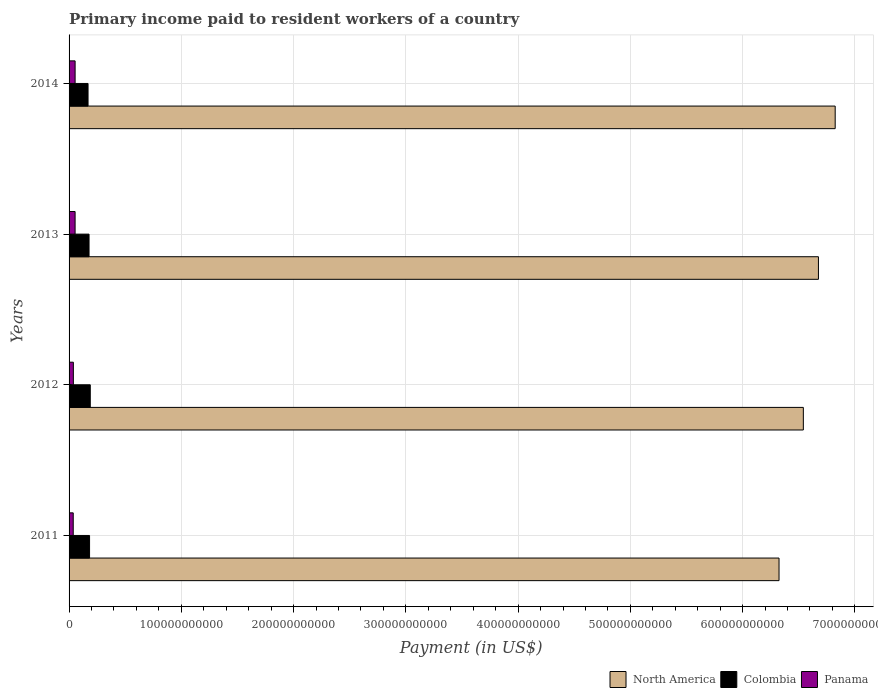Are the number of bars on each tick of the Y-axis equal?
Make the answer very short. Yes. What is the label of the 2nd group of bars from the top?
Provide a short and direct response. 2013. What is the amount paid to workers in North America in 2014?
Provide a short and direct response. 6.82e+11. Across all years, what is the maximum amount paid to workers in Colombia?
Your response must be concise. 1.89e+1. Across all years, what is the minimum amount paid to workers in Colombia?
Keep it short and to the point. 1.69e+1. What is the total amount paid to workers in Colombia in the graph?
Offer a very short reply. 7.18e+1. What is the difference between the amount paid to workers in North America in 2013 and that in 2014?
Give a very brief answer. -1.49e+1. What is the difference between the amount paid to workers in Panama in 2011 and the amount paid to workers in Colombia in 2012?
Your answer should be very brief. -1.52e+1. What is the average amount paid to workers in North America per year?
Provide a short and direct response. 6.59e+11. In the year 2012, what is the difference between the amount paid to workers in Colombia and amount paid to workers in Panama?
Your answer should be very brief. 1.51e+1. What is the ratio of the amount paid to workers in Colombia in 2012 to that in 2013?
Your response must be concise. 1.06. What is the difference between the highest and the second highest amount paid to workers in Panama?
Make the answer very short. 8.10e+06. What is the difference between the highest and the lowest amount paid to workers in North America?
Offer a terse response. 5.00e+1. Is the sum of the amount paid to workers in Colombia in 2011 and 2012 greater than the maximum amount paid to workers in Panama across all years?
Ensure brevity in your answer.  Yes. What does the 1st bar from the top in 2013 represents?
Keep it short and to the point. Panama. What does the 3rd bar from the bottom in 2012 represents?
Your answer should be compact. Panama. Is it the case that in every year, the sum of the amount paid to workers in North America and amount paid to workers in Colombia is greater than the amount paid to workers in Panama?
Your response must be concise. Yes. How many bars are there?
Your answer should be compact. 12. Are all the bars in the graph horizontal?
Ensure brevity in your answer.  Yes. How many years are there in the graph?
Give a very brief answer. 4. What is the difference between two consecutive major ticks on the X-axis?
Your response must be concise. 1.00e+11. Are the values on the major ticks of X-axis written in scientific E-notation?
Provide a succinct answer. No. Does the graph contain grids?
Ensure brevity in your answer.  Yes. How many legend labels are there?
Provide a short and direct response. 3. How are the legend labels stacked?
Make the answer very short. Horizontal. What is the title of the graph?
Give a very brief answer. Primary income paid to resident workers of a country. What is the label or title of the X-axis?
Offer a terse response. Payment (in US$). What is the label or title of the Y-axis?
Give a very brief answer. Years. What is the Payment (in US$) in North America in 2011?
Provide a short and direct response. 6.32e+11. What is the Payment (in US$) in Colombia in 2011?
Provide a succinct answer. 1.83e+1. What is the Payment (in US$) of Panama in 2011?
Keep it short and to the point. 3.71e+09. What is the Payment (in US$) of North America in 2012?
Provide a succinct answer. 6.54e+11. What is the Payment (in US$) in Colombia in 2012?
Your answer should be very brief. 1.89e+1. What is the Payment (in US$) of Panama in 2012?
Your answer should be very brief. 3.83e+09. What is the Payment (in US$) of North America in 2013?
Provide a succinct answer. 6.68e+11. What is the Payment (in US$) of Colombia in 2013?
Offer a very short reply. 1.78e+1. What is the Payment (in US$) of Panama in 2013?
Offer a terse response. 5.37e+09. What is the Payment (in US$) in North America in 2014?
Your response must be concise. 6.82e+11. What is the Payment (in US$) of Colombia in 2014?
Your answer should be very brief. 1.69e+1. What is the Payment (in US$) in Panama in 2014?
Give a very brief answer. 5.37e+09. Across all years, what is the maximum Payment (in US$) in North America?
Your response must be concise. 6.82e+11. Across all years, what is the maximum Payment (in US$) in Colombia?
Make the answer very short. 1.89e+1. Across all years, what is the maximum Payment (in US$) of Panama?
Your response must be concise. 5.37e+09. Across all years, what is the minimum Payment (in US$) in North America?
Make the answer very short. 6.32e+11. Across all years, what is the minimum Payment (in US$) in Colombia?
Give a very brief answer. 1.69e+1. Across all years, what is the minimum Payment (in US$) in Panama?
Provide a succinct answer. 3.71e+09. What is the total Payment (in US$) of North America in the graph?
Your answer should be very brief. 2.64e+12. What is the total Payment (in US$) in Colombia in the graph?
Provide a short and direct response. 7.18e+1. What is the total Payment (in US$) in Panama in the graph?
Your response must be concise. 1.83e+1. What is the difference between the Payment (in US$) in North America in 2011 and that in 2012?
Provide a short and direct response. -2.17e+1. What is the difference between the Payment (in US$) in Colombia in 2011 and that in 2012?
Ensure brevity in your answer.  -6.22e+08. What is the difference between the Payment (in US$) in Panama in 2011 and that in 2012?
Give a very brief answer. -1.19e+08. What is the difference between the Payment (in US$) of North America in 2011 and that in 2013?
Give a very brief answer. -3.51e+1. What is the difference between the Payment (in US$) in Colombia in 2011 and that in 2013?
Provide a succinct answer. 4.71e+08. What is the difference between the Payment (in US$) of Panama in 2011 and that in 2013?
Your answer should be compact. -1.66e+09. What is the difference between the Payment (in US$) in North America in 2011 and that in 2014?
Offer a very short reply. -5.00e+1. What is the difference between the Payment (in US$) in Colombia in 2011 and that in 2014?
Provide a short and direct response. 1.36e+09. What is the difference between the Payment (in US$) in Panama in 2011 and that in 2014?
Your answer should be compact. -1.67e+09. What is the difference between the Payment (in US$) of North America in 2012 and that in 2013?
Keep it short and to the point. -1.34e+1. What is the difference between the Payment (in US$) of Colombia in 2012 and that in 2013?
Your answer should be very brief. 1.09e+09. What is the difference between the Payment (in US$) in Panama in 2012 and that in 2013?
Your answer should be compact. -1.54e+09. What is the difference between the Payment (in US$) in North America in 2012 and that in 2014?
Make the answer very short. -2.84e+1. What is the difference between the Payment (in US$) in Colombia in 2012 and that in 2014?
Ensure brevity in your answer.  1.98e+09. What is the difference between the Payment (in US$) in Panama in 2012 and that in 2014?
Provide a succinct answer. -1.55e+09. What is the difference between the Payment (in US$) of North America in 2013 and that in 2014?
Make the answer very short. -1.49e+1. What is the difference between the Payment (in US$) of Colombia in 2013 and that in 2014?
Your answer should be very brief. 8.88e+08. What is the difference between the Payment (in US$) of Panama in 2013 and that in 2014?
Ensure brevity in your answer.  -8.10e+06. What is the difference between the Payment (in US$) of North America in 2011 and the Payment (in US$) of Colombia in 2012?
Give a very brief answer. 6.14e+11. What is the difference between the Payment (in US$) in North America in 2011 and the Payment (in US$) in Panama in 2012?
Offer a terse response. 6.29e+11. What is the difference between the Payment (in US$) in Colombia in 2011 and the Payment (in US$) in Panama in 2012?
Your answer should be compact. 1.44e+1. What is the difference between the Payment (in US$) in North America in 2011 and the Payment (in US$) in Colombia in 2013?
Give a very brief answer. 6.15e+11. What is the difference between the Payment (in US$) of North America in 2011 and the Payment (in US$) of Panama in 2013?
Make the answer very short. 6.27e+11. What is the difference between the Payment (in US$) in Colombia in 2011 and the Payment (in US$) in Panama in 2013?
Your answer should be very brief. 1.29e+1. What is the difference between the Payment (in US$) of North America in 2011 and the Payment (in US$) of Colombia in 2014?
Provide a short and direct response. 6.16e+11. What is the difference between the Payment (in US$) in North America in 2011 and the Payment (in US$) in Panama in 2014?
Keep it short and to the point. 6.27e+11. What is the difference between the Payment (in US$) of Colombia in 2011 and the Payment (in US$) of Panama in 2014?
Provide a succinct answer. 1.29e+1. What is the difference between the Payment (in US$) of North America in 2012 and the Payment (in US$) of Colombia in 2013?
Ensure brevity in your answer.  6.36e+11. What is the difference between the Payment (in US$) of North America in 2012 and the Payment (in US$) of Panama in 2013?
Offer a very short reply. 6.49e+11. What is the difference between the Payment (in US$) of Colombia in 2012 and the Payment (in US$) of Panama in 2013?
Your response must be concise. 1.35e+1. What is the difference between the Payment (in US$) of North America in 2012 and the Payment (in US$) of Colombia in 2014?
Provide a short and direct response. 6.37e+11. What is the difference between the Payment (in US$) of North America in 2012 and the Payment (in US$) of Panama in 2014?
Offer a terse response. 6.49e+11. What is the difference between the Payment (in US$) of Colombia in 2012 and the Payment (in US$) of Panama in 2014?
Provide a short and direct response. 1.35e+1. What is the difference between the Payment (in US$) in North America in 2013 and the Payment (in US$) in Colombia in 2014?
Make the answer very short. 6.51e+11. What is the difference between the Payment (in US$) in North America in 2013 and the Payment (in US$) in Panama in 2014?
Provide a short and direct response. 6.62e+11. What is the difference between the Payment (in US$) in Colombia in 2013 and the Payment (in US$) in Panama in 2014?
Provide a short and direct response. 1.24e+1. What is the average Payment (in US$) of North America per year?
Ensure brevity in your answer.  6.59e+11. What is the average Payment (in US$) in Colombia per year?
Provide a succinct answer. 1.80e+1. What is the average Payment (in US$) in Panama per year?
Offer a very short reply. 4.57e+09. In the year 2011, what is the difference between the Payment (in US$) in North America and Payment (in US$) in Colombia?
Your answer should be compact. 6.14e+11. In the year 2011, what is the difference between the Payment (in US$) of North America and Payment (in US$) of Panama?
Give a very brief answer. 6.29e+11. In the year 2011, what is the difference between the Payment (in US$) in Colombia and Payment (in US$) in Panama?
Offer a very short reply. 1.46e+1. In the year 2012, what is the difference between the Payment (in US$) in North America and Payment (in US$) in Colombia?
Your response must be concise. 6.35e+11. In the year 2012, what is the difference between the Payment (in US$) in North America and Payment (in US$) in Panama?
Offer a terse response. 6.50e+11. In the year 2012, what is the difference between the Payment (in US$) of Colombia and Payment (in US$) of Panama?
Give a very brief answer. 1.51e+1. In the year 2013, what is the difference between the Payment (in US$) of North America and Payment (in US$) of Colombia?
Offer a terse response. 6.50e+11. In the year 2013, what is the difference between the Payment (in US$) of North America and Payment (in US$) of Panama?
Keep it short and to the point. 6.62e+11. In the year 2013, what is the difference between the Payment (in US$) of Colombia and Payment (in US$) of Panama?
Your answer should be compact. 1.24e+1. In the year 2014, what is the difference between the Payment (in US$) in North America and Payment (in US$) in Colombia?
Your response must be concise. 6.66e+11. In the year 2014, what is the difference between the Payment (in US$) in North America and Payment (in US$) in Panama?
Give a very brief answer. 6.77e+11. In the year 2014, what is the difference between the Payment (in US$) of Colombia and Payment (in US$) of Panama?
Your answer should be very brief. 1.15e+1. What is the ratio of the Payment (in US$) in North America in 2011 to that in 2012?
Your response must be concise. 0.97. What is the ratio of the Payment (in US$) in Colombia in 2011 to that in 2012?
Offer a terse response. 0.97. What is the ratio of the Payment (in US$) of Panama in 2011 to that in 2012?
Keep it short and to the point. 0.97. What is the ratio of the Payment (in US$) of Colombia in 2011 to that in 2013?
Make the answer very short. 1.03. What is the ratio of the Payment (in US$) in Panama in 2011 to that in 2013?
Provide a succinct answer. 0.69. What is the ratio of the Payment (in US$) in North America in 2011 to that in 2014?
Your answer should be compact. 0.93. What is the ratio of the Payment (in US$) of Colombia in 2011 to that in 2014?
Provide a short and direct response. 1.08. What is the ratio of the Payment (in US$) in Panama in 2011 to that in 2014?
Your answer should be compact. 0.69. What is the ratio of the Payment (in US$) in North America in 2012 to that in 2013?
Make the answer very short. 0.98. What is the ratio of the Payment (in US$) of Colombia in 2012 to that in 2013?
Provide a succinct answer. 1.06. What is the ratio of the Payment (in US$) of Panama in 2012 to that in 2013?
Keep it short and to the point. 0.71. What is the ratio of the Payment (in US$) in North America in 2012 to that in 2014?
Provide a short and direct response. 0.96. What is the ratio of the Payment (in US$) in Colombia in 2012 to that in 2014?
Provide a short and direct response. 1.12. What is the ratio of the Payment (in US$) of Panama in 2012 to that in 2014?
Your answer should be compact. 0.71. What is the ratio of the Payment (in US$) of North America in 2013 to that in 2014?
Make the answer very short. 0.98. What is the ratio of the Payment (in US$) of Colombia in 2013 to that in 2014?
Ensure brevity in your answer.  1.05. What is the difference between the highest and the second highest Payment (in US$) of North America?
Provide a short and direct response. 1.49e+1. What is the difference between the highest and the second highest Payment (in US$) in Colombia?
Your answer should be very brief. 6.22e+08. What is the difference between the highest and the second highest Payment (in US$) in Panama?
Give a very brief answer. 8.10e+06. What is the difference between the highest and the lowest Payment (in US$) of North America?
Make the answer very short. 5.00e+1. What is the difference between the highest and the lowest Payment (in US$) of Colombia?
Your answer should be very brief. 1.98e+09. What is the difference between the highest and the lowest Payment (in US$) of Panama?
Your answer should be very brief. 1.67e+09. 